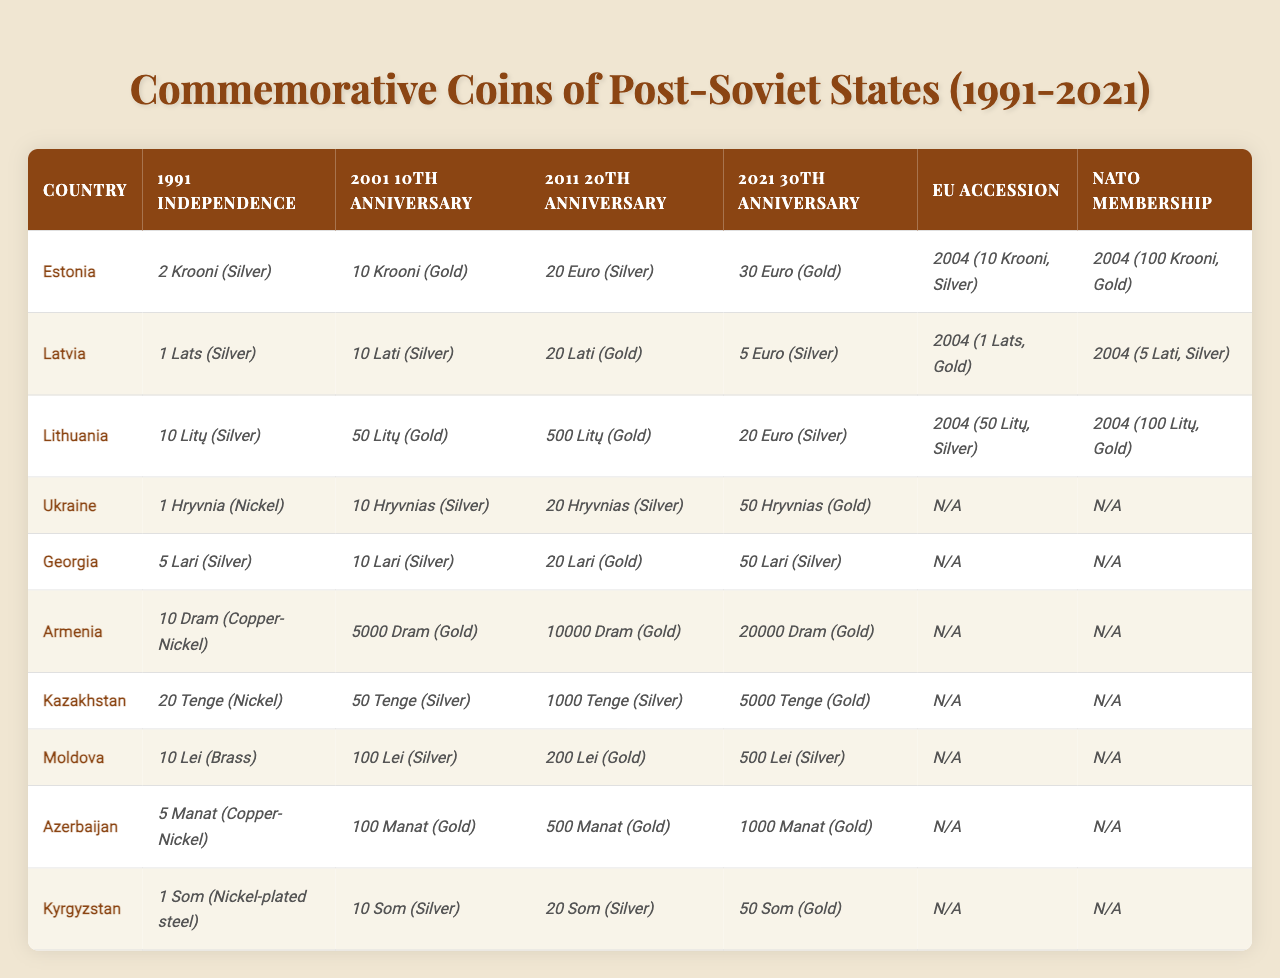What commemorative coin did Estonia release to mark its independence in 1991? According to the table, Estonia issued a "2 Krooni (Silver)" coin to commemorate its independence in 1991.
Answer: 2 Krooni (Silver) Which country released a commemorative coin for both the 20th anniversary of independence in 2011 and the 30th anniversary in 2021? Looking at the table, Ukraine is the country that issued a "20 Hryvnias (Silver)" coin for the 20th anniversary in 2011 and a "50 Hryvnias (Gold)" coin for the 30th anniversary in 2021.
Answer: Ukraine How many different types of coins did Georgia issue from 1991 to 2021? Georgia issued four different types of coins for the years specified: "5 Lari (Silver)” (1991), “10 Lari (Silver)” (2001), “20 Lari (Gold)” (2011), and “50 Lari (Silver)” (2021). Therefore, the total is 4 distinct coins.
Answer: 4 What is the total value of commemorative coins released by Latvia in 2011? Latvia released a "500 Litų (Gold)" coin for the 20th anniversary in 2011. Since there is only one coin released in that year, the total value is simply 500 Litų.
Answer: 500 Litų Did any country release commemorative coins for both EU accession and NATO membership in 2004? Yes, both Estonia, Latvia, and Lithuania released commemorative coins for their EU accession and NATO membership in 2004.
Answer: Yes Which country’s commemorative coin for NATO membership was the most valuable? Lithuania released a "100 Litų (Gold)" coin for NATO membership in 2004, which is the highest value among the NATO membership coins in the table.
Answer: Lithuania In 2004, which country's NATO membership coin was the least valuable? The table shows that Latvia released a "5 Lati (Silver)" coin for NATO membership in 2004, which is less valuable than the other NATO coins from Estonia and Lithuania.
Answer: Latvia If we compare the commemorative coins for the 2011 and 2021 anniversaries, which country increased the value of their commemorative coins the most? Comparing the coins for 2011 and 2021, Georgia released a "20 Lari (Gold)" in 2011 and a "50 Lari (Silver)" coin in 2021. The increase in value is 50 Lari - 20 Lari = 30 Lari. This is the maximum increase observed among the countries.
Answer: Georgia What type of coin has Armenia released for its independence in 1991? Armenia issued a "10 Dram (Copper-Nickel)" coin to commemorate its independence in 1991, as per the table.
Answer: 10 Dram (Copper-Nickel) Which country's commemorative coins for independence have the least metal value overall when including coins from 1991, 2001, 2011, and 2021? A thorough assessment of values indicates that Armenia has the least overall metal value across the years specified: 10 Dram (1991), 5000 Dram (2001), 10000 Dram (2011), and 20000 Dram (2021). The overall least value can be assessed qualitatively as the simplest coin overall.
Answer: Armenia 